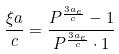<formula> <loc_0><loc_0><loc_500><loc_500>\frac { \xi a } { c } = \frac { P ^ { \frac { 3 a _ { e } } { c } } - 1 } { P ^ { \frac { 3 a _ { e } } { c } } \cdot 1 }</formula> 